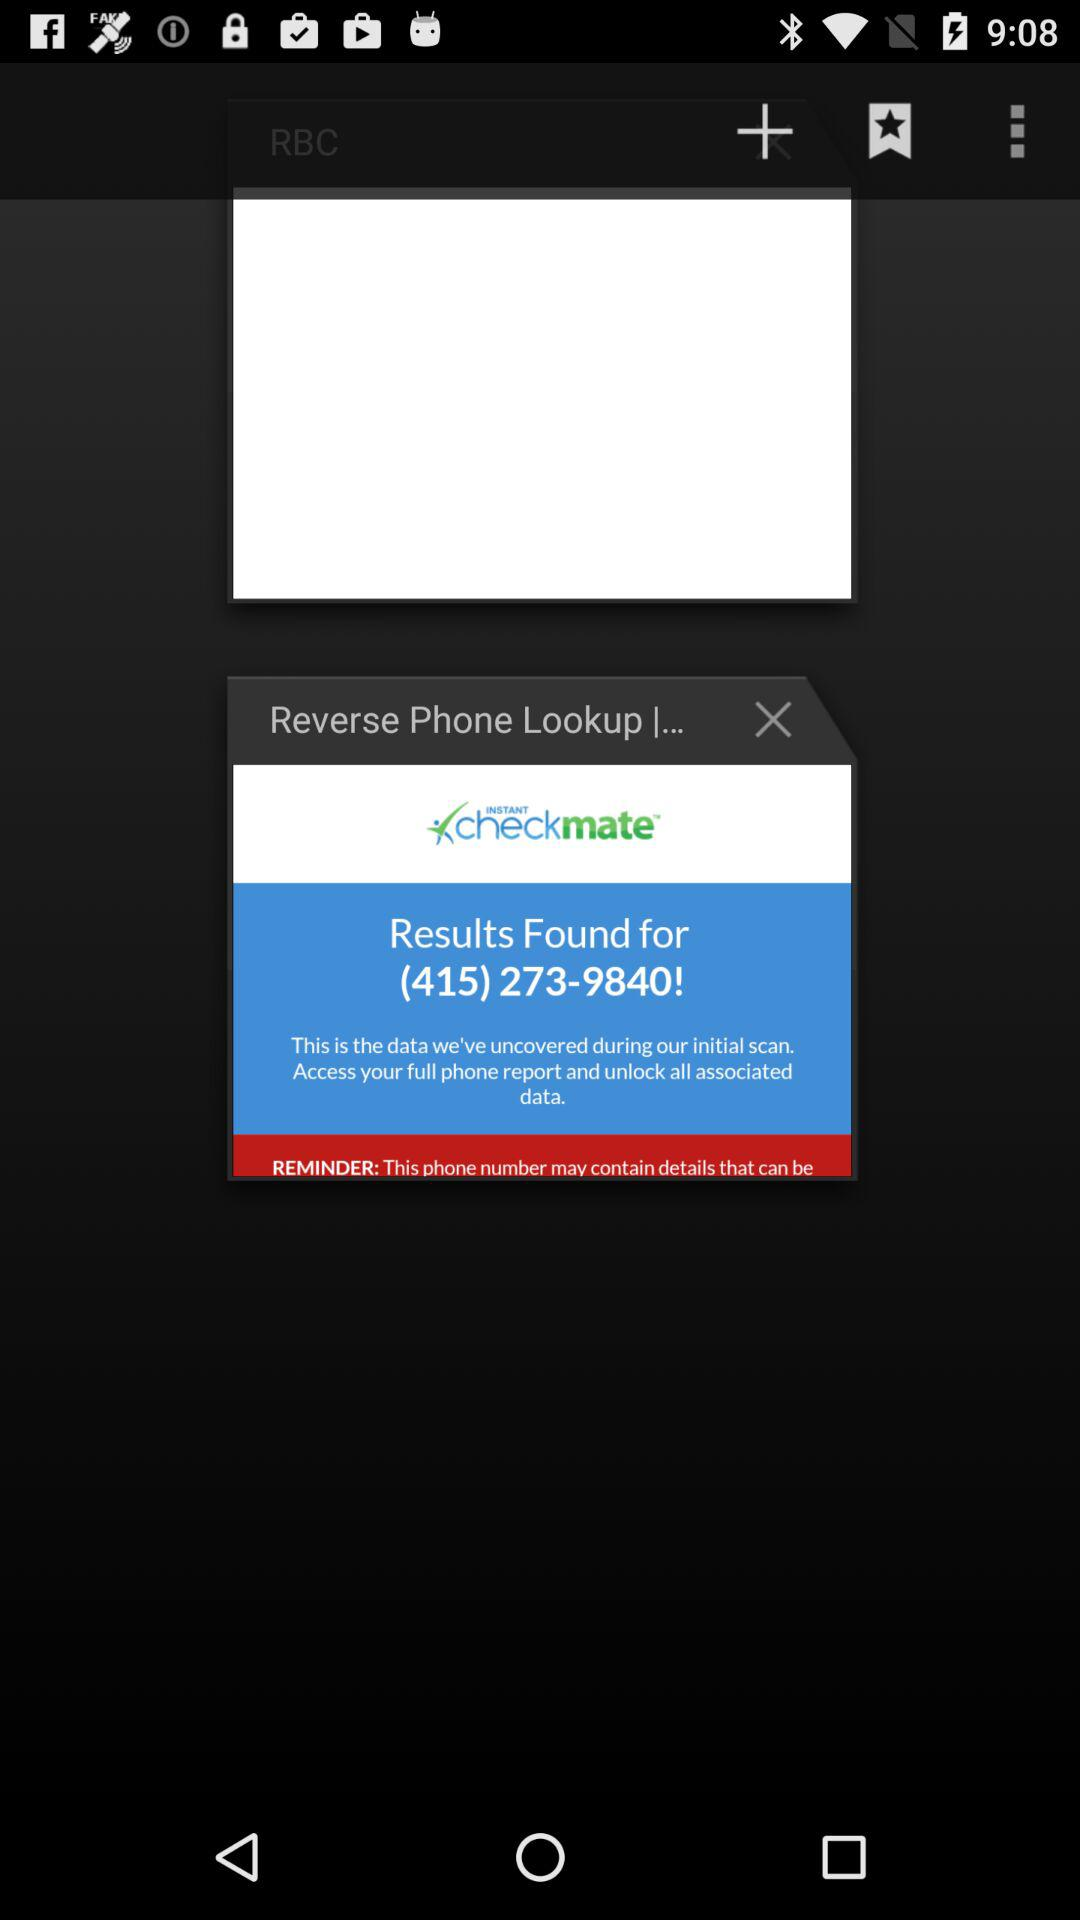For what number is the result found? The result is found for (415) 273-9840. 